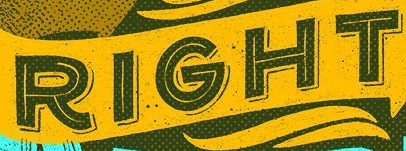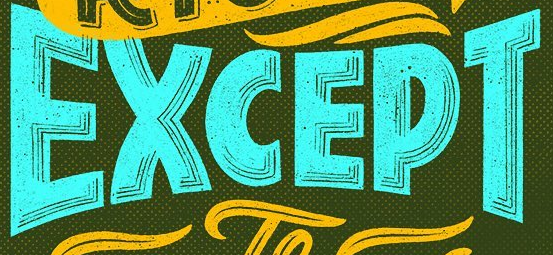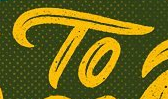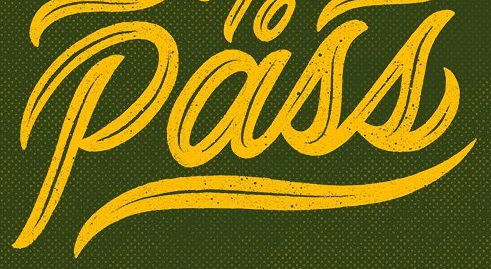Read the text content from these images in order, separated by a semicolon. RIGHT; EXCEPT; TO; Pass 